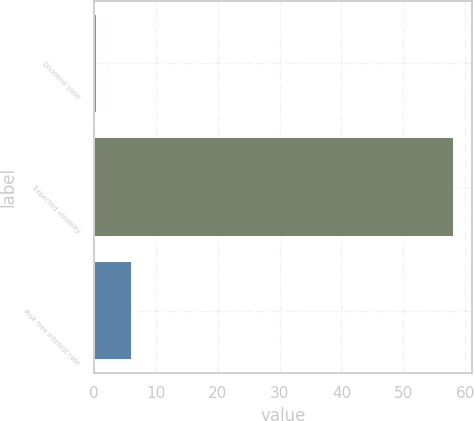Convert chart to OTSL. <chart><loc_0><loc_0><loc_500><loc_500><bar_chart><fcel>Dividend yield<fcel>Expected volatility<fcel>Risk free interest rate<nl><fcel>0.44<fcel>58.2<fcel>6.22<nl></chart> 